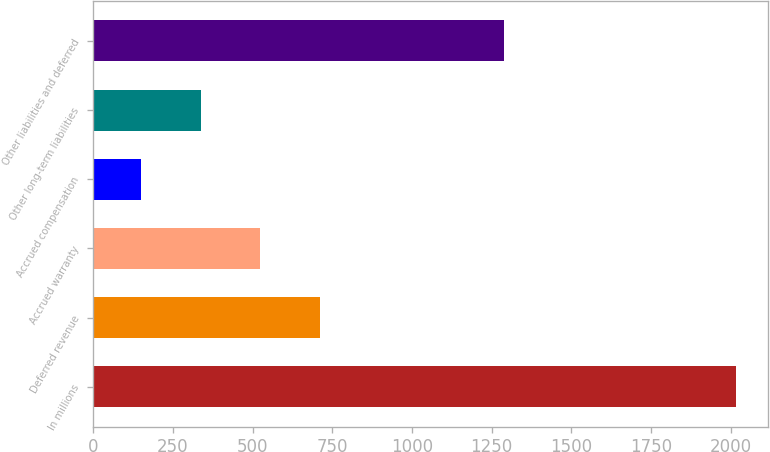Convert chart. <chart><loc_0><loc_0><loc_500><loc_500><bar_chart><fcel>In millions<fcel>Deferred revenue<fcel>Accrued warranty<fcel>Accrued compensation<fcel>Other long-term liabilities<fcel>Other liabilities and deferred<nl><fcel>2016<fcel>710.5<fcel>524<fcel>151<fcel>337.5<fcel>1289<nl></chart> 